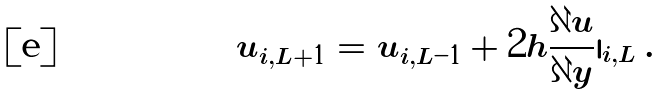Convert formula to latex. <formula><loc_0><loc_0><loc_500><loc_500>u _ { i , L + 1 } = u _ { i , L - 1 } + 2 h \frac { \partial u } { \partial y } | _ { i , L } \, .</formula> 